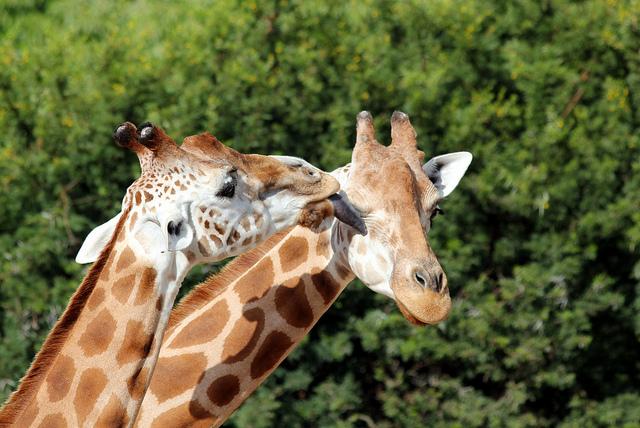Is the area fenced?
Write a very short answer. No. Is the giraffe's head wider than its neck?
Short answer required. Yes. Are the giraffes looking to the left or right?
Be succinct. Right. What color are the trees?
Answer briefly. Green. Are there bushes or trees in the background?
Concise answer only. Yes. What is the giraffe doing?
Keep it brief. Licking. Are these animals in the wild?
Be succinct. Yes. Is the sun shining?
Give a very brief answer. Yes. Are the giraffes touching?
Keep it brief. Yes. 